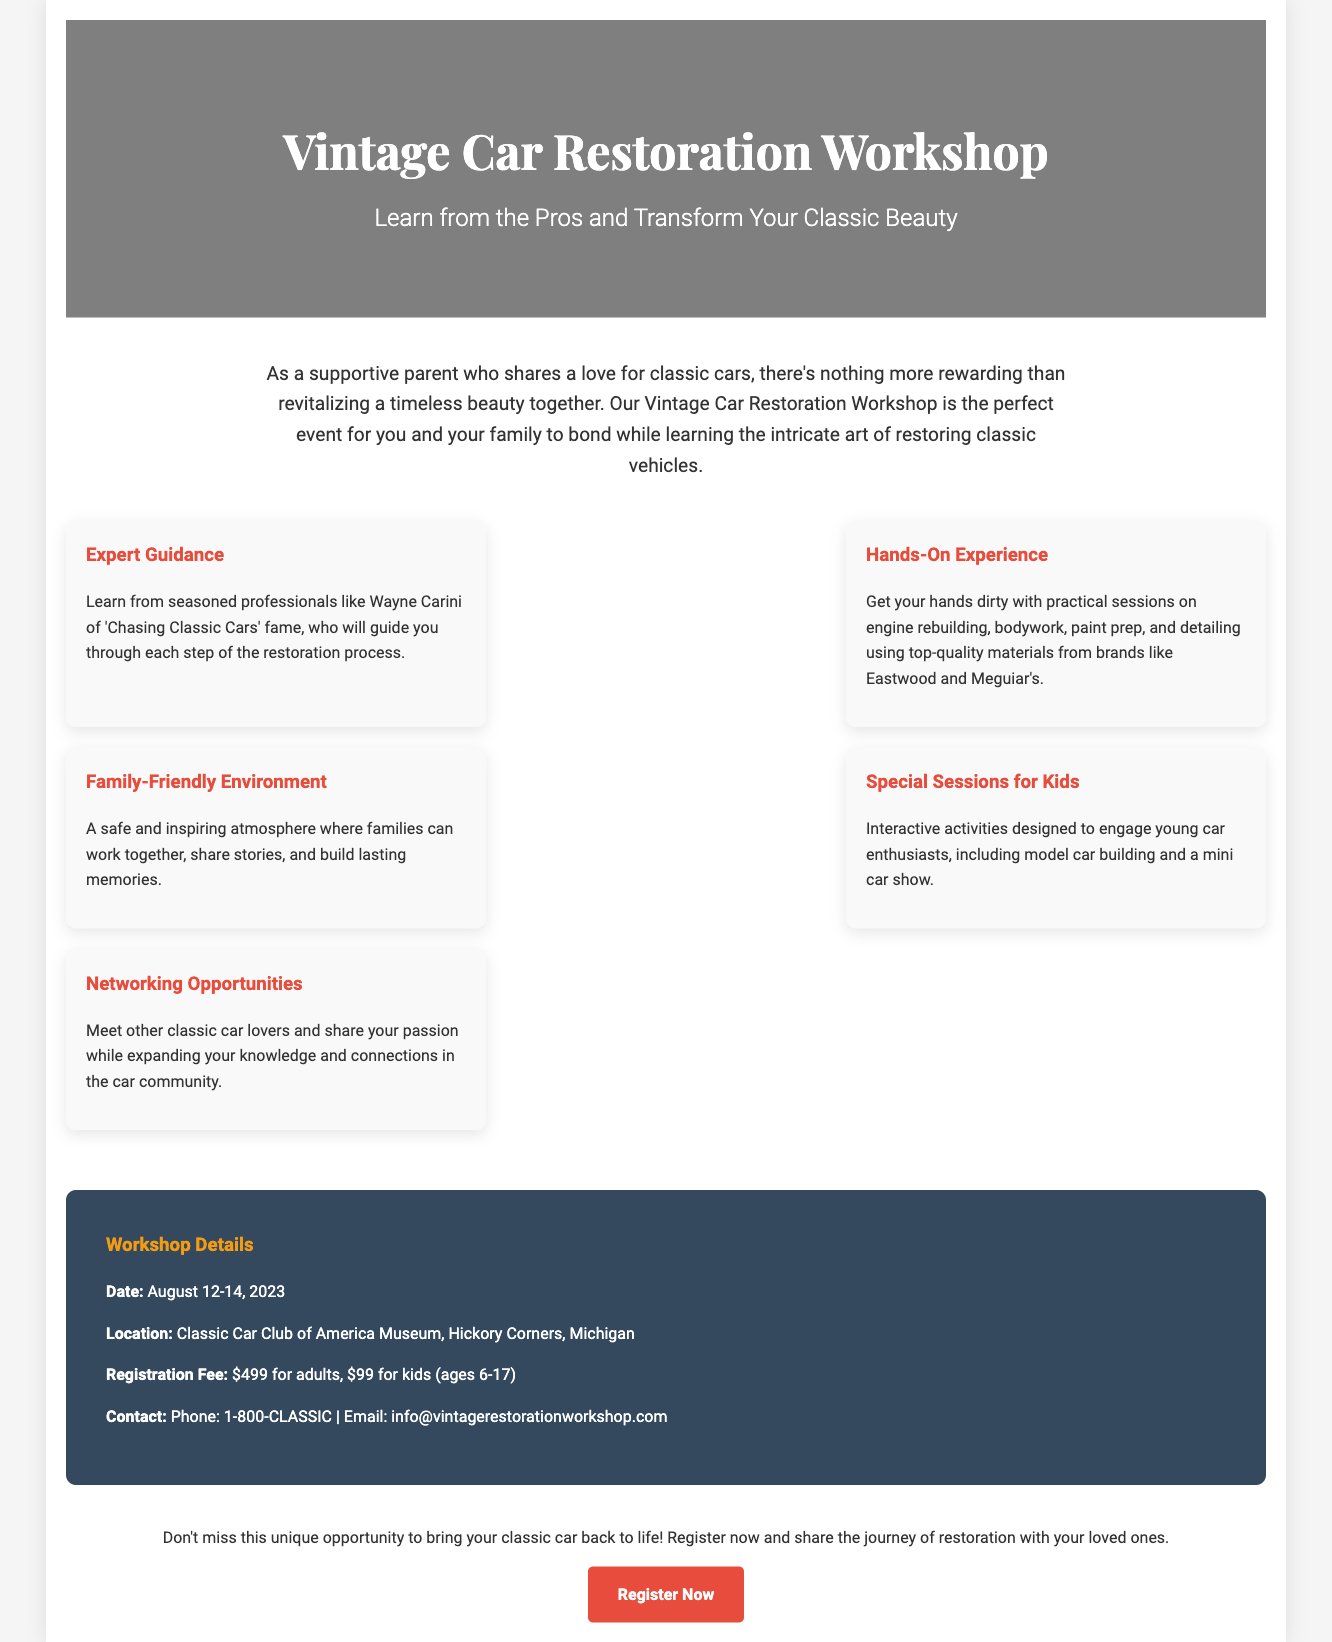What is the date of the workshop? The date of the workshop is specified in the details section as August 12-14, 2023.
Answer: August 12-14, 2023 Who is one of the professionals guiding the workshop? The document mentions Wayne Carini as a seasoned professional guiding the restoration process.
Answer: Wayne Carini What is the location of the workshop? The location of the workshop is provided as the Classic Car Club of America Museum, Hickory Corners, Michigan.
Answer: Classic Car Club of America Museum, Hickory Corners, Michigan What is the registration fee for kids? The document states that the registration fee for kids (ages 6-17) is $99.
Answer: $99 What type of environment is offered at the workshop? The document describes the environment as family-friendly where families can work together and share stories.
Answer: Family-Friendly Environment How many highlights are provided in the workshop overview? The overview lists five highlights for the workshop experience.
Answer: Five What kind of activities are included for kids at the workshop? The document mentions interactive activities like model car building and a mini car show designed for kids.
Answer: Model car building and mini car show What is the contact phone number for inquiries? The contact phone number is provided as 1-800-CLASSIC in the details section.
Answer: 1-800-CLASSIC 